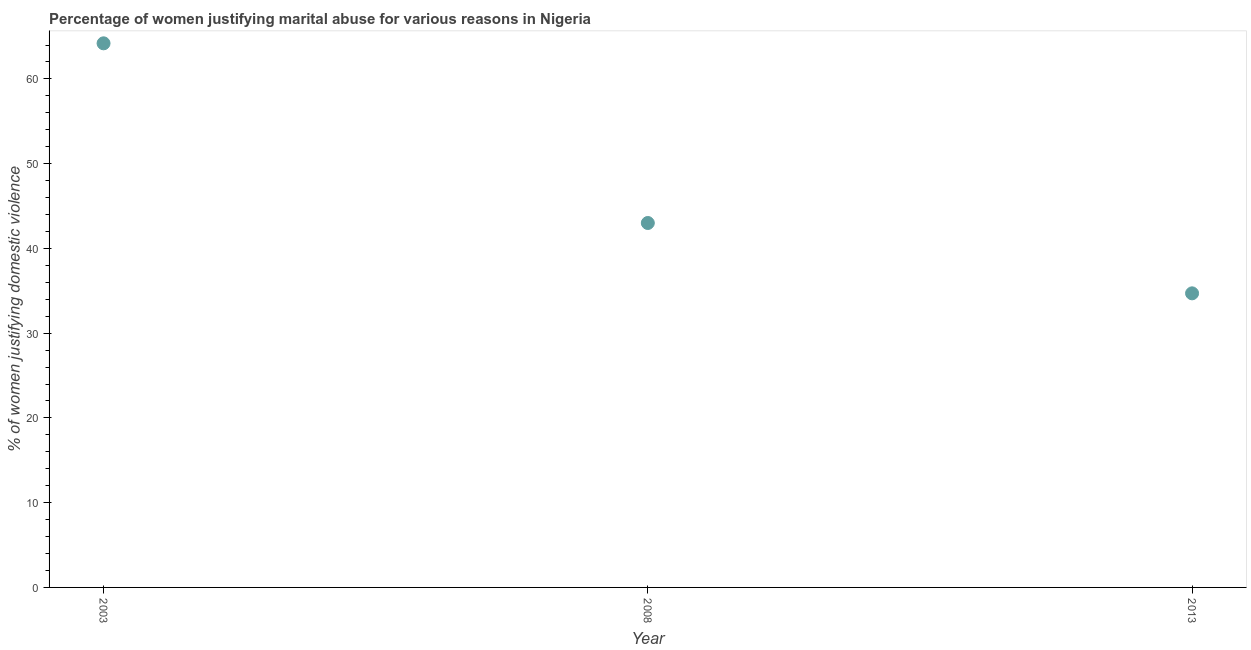Across all years, what is the maximum percentage of women justifying marital abuse?
Your response must be concise. 64.2. Across all years, what is the minimum percentage of women justifying marital abuse?
Your response must be concise. 34.7. What is the sum of the percentage of women justifying marital abuse?
Provide a succinct answer. 141.9. What is the difference between the percentage of women justifying marital abuse in 2003 and 2008?
Keep it short and to the point. 21.2. What is the average percentage of women justifying marital abuse per year?
Give a very brief answer. 47.3. What is the median percentage of women justifying marital abuse?
Offer a terse response. 43. In how many years, is the percentage of women justifying marital abuse greater than 52 %?
Provide a succinct answer. 1. Do a majority of the years between 2013 and 2008 (inclusive) have percentage of women justifying marital abuse greater than 24 %?
Your answer should be very brief. No. What is the ratio of the percentage of women justifying marital abuse in 2003 to that in 2008?
Provide a short and direct response. 1.49. Is the difference between the percentage of women justifying marital abuse in 2003 and 2008 greater than the difference between any two years?
Provide a short and direct response. No. What is the difference between the highest and the second highest percentage of women justifying marital abuse?
Offer a very short reply. 21.2. Is the sum of the percentage of women justifying marital abuse in 2008 and 2013 greater than the maximum percentage of women justifying marital abuse across all years?
Give a very brief answer. Yes. What is the difference between the highest and the lowest percentage of women justifying marital abuse?
Provide a short and direct response. 29.5. In how many years, is the percentage of women justifying marital abuse greater than the average percentage of women justifying marital abuse taken over all years?
Your answer should be very brief. 1. How many years are there in the graph?
Offer a very short reply. 3. Are the values on the major ticks of Y-axis written in scientific E-notation?
Give a very brief answer. No. Does the graph contain any zero values?
Your response must be concise. No. Does the graph contain grids?
Keep it short and to the point. No. What is the title of the graph?
Your answer should be compact. Percentage of women justifying marital abuse for various reasons in Nigeria. What is the label or title of the Y-axis?
Provide a short and direct response. % of women justifying domestic violence. What is the % of women justifying domestic violence in 2003?
Keep it short and to the point. 64.2. What is the % of women justifying domestic violence in 2008?
Your answer should be very brief. 43. What is the % of women justifying domestic violence in 2013?
Your response must be concise. 34.7. What is the difference between the % of women justifying domestic violence in 2003 and 2008?
Ensure brevity in your answer.  21.2. What is the difference between the % of women justifying domestic violence in 2003 and 2013?
Give a very brief answer. 29.5. What is the ratio of the % of women justifying domestic violence in 2003 to that in 2008?
Your answer should be compact. 1.49. What is the ratio of the % of women justifying domestic violence in 2003 to that in 2013?
Your response must be concise. 1.85. What is the ratio of the % of women justifying domestic violence in 2008 to that in 2013?
Provide a short and direct response. 1.24. 